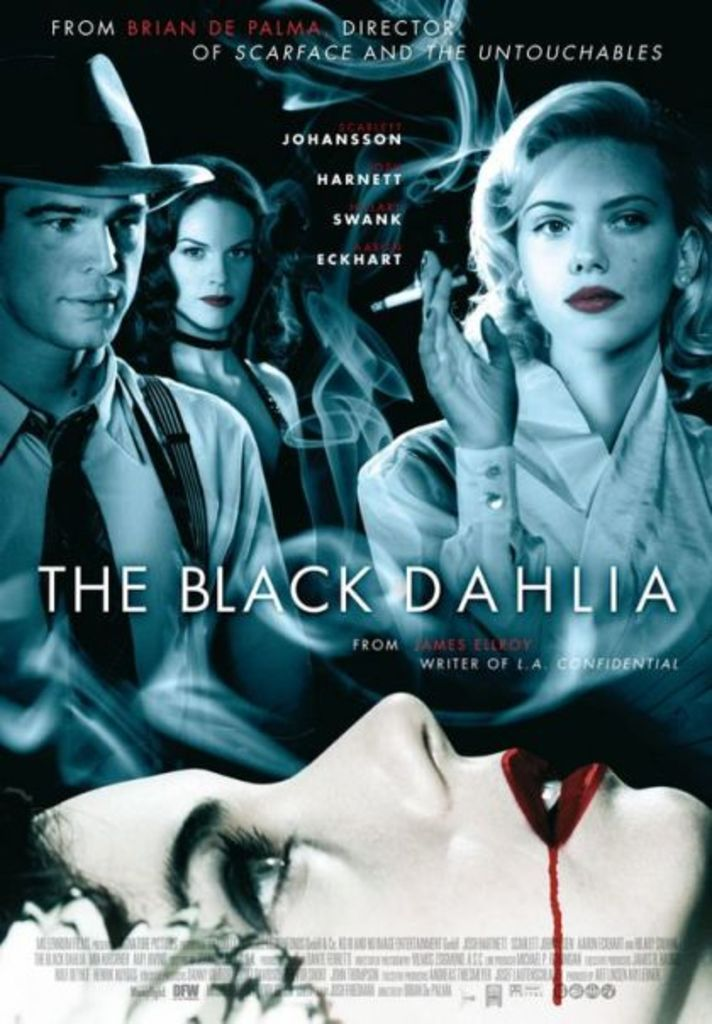Provide a one-sentence caption for the provided image. The movie poster for 'The Black Dahlia' features prominent cast members Scarlett Johansson, Josh Hartnett, and Hilary Swank, set against a mysterious and noir-inspired backdrop, hinting at the film's thriller elements. 